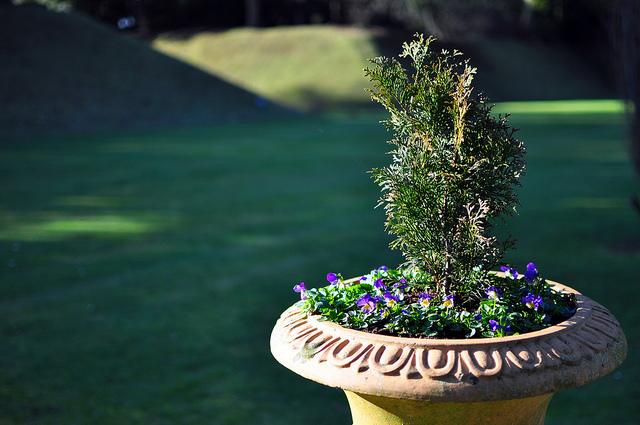Where are the flowers?
Answer briefly. Pot. What color is the grass?
Short answer required. Green. Are the flowers planted in the ground?
Write a very short answer. No. Do these flowers bloom in spring only?
Be succinct. Yes. 